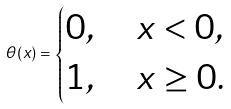<formula> <loc_0><loc_0><loc_500><loc_500>\theta ( x ) = \begin{cases} 0 , \quad x < 0 , \\ 1 , \quad x \geq 0 . \end{cases}</formula> 